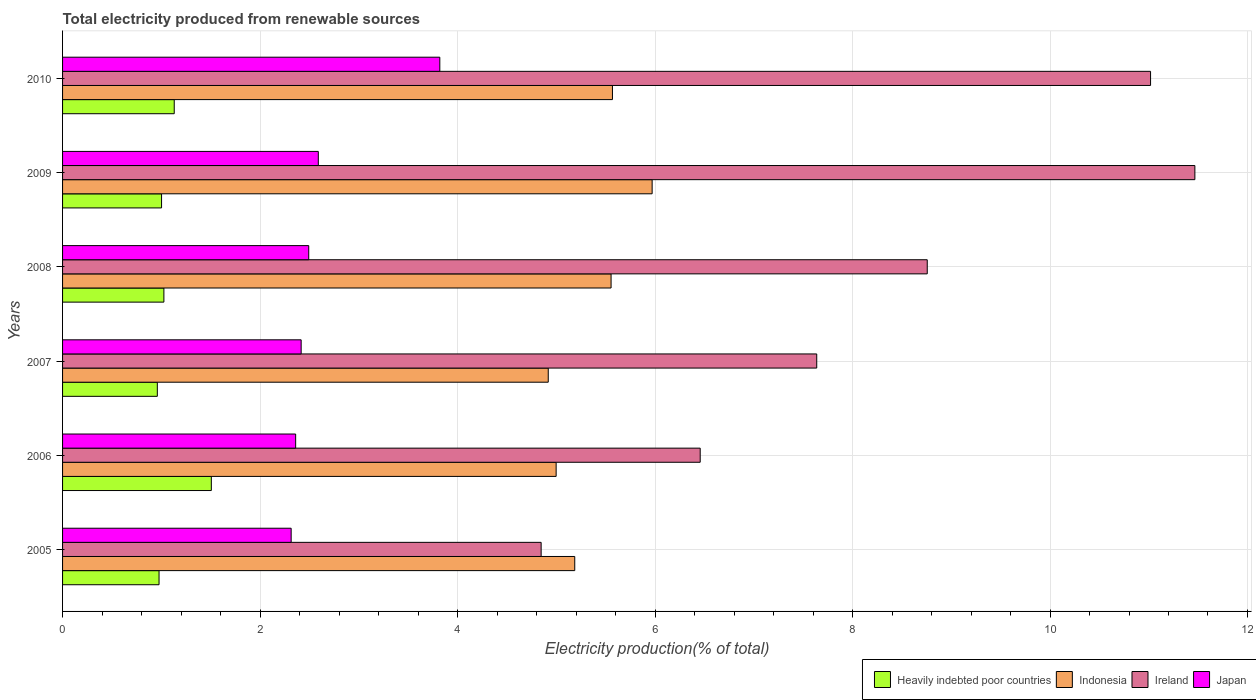How many different coloured bars are there?
Provide a succinct answer. 4. How many groups of bars are there?
Keep it short and to the point. 6. In how many cases, is the number of bars for a given year not equal to the number of legend labels?
Offer a terse response. 0. What is the total electricity produced in Heavily indebted poor countries in 2007?
Offer a very short reply. 0.96. Across all years, what is the maximum total electricity produced in Japan?
Your response must be concise. 3.82. Across all years, what is the minimum total electricity produced in Ireland?
Provide a short and direct response. 4.85. What is the total total electricity produced in Indonesia in the graph?
Ensure brevity in your answer.  32.2. What is the difference between the total electricity produced in Indonesia in 2005 and that in 2010?
Your response must be concise. -0.38. What is the difference between the total electricity produced in Japan in 2009 and the total electricity produced in Ireland in 2008?
Offer a terse response. -6.17. What is the average total electricity produced in Indonesia per year?
Your response must be concise. 5.37. In the year 2008, what is the difference between the total electricity produced in Indonesia and total electricity produced in Japan?
Ensure brevity in your answer.  3.06. What is the ratio of the total electricity produced in Heavily indebted poor countries in 2006 to that in 2007?
Keep it short and to the point. 1.57. Is the total electricity produced in Indonesia in 2009 less than that in 2010?
Ensure brevity in your answer.  No. Is the difference between the total electricity produced in Indonesia in 2005 and 2009 greater than the difference between the total electricity produced in Japan in 2005 and 2009?
Offer a terse response. No. What is the difference between the highest and the second highest total electricity produced in Indonesia?
Give a very brief answer. 0.4. What is the difference between the highest and the lowest total electricity produced in Japan?
Make the answer very short. 1.51. What does the 3rd bar from the top in 2009 represents?
Keep it short and to the point. Indonesia. What does the 1st bar from the bottom in 2005 represents?
Your answer should be very brief. Heavily indebted poor countries. Is it the case that in every year, the sum of the total electricity produced in Japan and total electricity produced in Heavily indebted poor countries is greater than the total electricity produced in Ireland?
Your answer should be very brief. No. How many bars are there?
Give a very brief answer. 24. Are all the bars in the graph horizontal?
Your answer should be very brief. Yes. What is the difference between two consecutive major ticks on the X-axis?
Keep it short and to the point. 2. Are the values on the major ticks of X-axis written in scientific E-notation?
Offer a very short reply. No. What is the title of the graph?
Offer a very short reply. Total electricity produced from renewable sources. Does "Grenada" appear as one of the legend labels in the graph?
Your answer should be very brief. No. What is the label or title of the Y-axis?
Your response must be concise. Years. What is the Electricity production(% of total) in Heavily indebted poor countries in 2005?
Ensure brevity in your answer.  0.98. What is the Electricity production(% of total) of Indonesia in 2005?
Ensure brevity in your answer.  5.19. What is the Electricity production(% of total) of Ireland in 2005?
Provide a succinct answer. 4.85. What is the Electricity production(% of total) in Japan in 2005?
Offer a terse response. 2.31. What is the Electricity production(% of total) of Heavily indebted poor countries in 2006?
Keep it short and to the point. 1.51. What is the Electricity production(% of total) in Indonesia in 2006?
Give a very brief answer. 5. What is the Electricity production(% of total) in Ireland in 2006?
Your answer should be compact. 6.46. What is the Electricity production(% of total) in Japan in 2006?
Your answer should be compact. 2.36. What is the Electricity production(% of total) of Heavily indebted poor countries in 2007?
Give a very brief answer. 0.96. What is the Electricity production(% of total) in Indonesia in 2007?
Your answer should be compact. 4.92. What is the Electricity production(% of total) in Ireland in 2007?
Your answer should be compact. 7.64. What is the Electricity production(% of total) of Japan in 2007?
Ensure brevity in your answer.  2.42. What is the Electricity production(% of total) of Heavily indebted poor countries in 2008?
Keep it short and to the point. 1.03. What is the Electricity production(% of total) in Indonesia in 2008?
Provide a succinct answer. 5.56. What is the Electricity production(% of total) of Ireland in 2008?
Give a very brief answer. 8.76. What is the Electricity production(% of total) of Japan in 2008?
Ensure brevity in your answer.  2.49. What is the Electricity production(% of total) of Heavily indebted poor countries in 2009?
Your answer should be compact. 1. What is the Electricity production(% of total) of Indonesia in 2009?
Provide a succinct answer. 5.97. What is the Electricity production(% of total) of Ireland in 2009?
Your answer should be compact. 11.47. What is the Electricity production(% of total) in Japan in 2009?
Provide a succinct answer. 2.59. What is the Electricity production(% of total) of Heavily indebted poor countries in 2010?
Your answer should be very brief. 1.13. What is the Electricity production(% of total) of Indonesia in 2010?
Your answer should be compact. 5.57. What is the Electricity production(% of total) in Ireland in 2010?
Your answer should be compact. 11.02. What is the Electricity production(% of total) in Japan in 2010?
Your response must be concise. 3.82. Across all years, what is the maximum Electricity production(% of total) of Heavily indebted poor countries?
Make the answer very short. 1.51. Across all years, what is the maximum Electricity production(% of total) in Indonesia?
Your response must be concise. 5.97. Across all years, what is the maximum Electricity production(% of total) in Ireland?
Give a very brief answer. 11.47. Across all years, what is the maximum Electricity production(% of total) in Japan?
Offer a very short reply. 3.82. Across all years, what is the minimum Electricity production(% of total) of Heavily indebted poor countries?
Give a very brief answer. 0.96. Across all years, what is the minimum Electricity production(% of total) in Indonesia?
Your answer should be compact. 4.92. Across all years, what is the minimum Electricity production(% of total) of Ireland?
Give a very brief answer. 4.85. Across all years, what is the minimum Electricity production(% of total) of Japan?
Your response must be concise. 2.31. What is the total Electricity production(% of total) in Heavily indebted poor countries in the graph?
Make the answer very short. 6.6. What is the total Electricity production(% of total) of Indonesia in the graph?
Your answer should be compact. 32.2. What is the total Electricity production(% of total) in Ireland in the graph?
Make the answer very short. 50.18. What is the total Electricity production(% of total) of Japan in the graph?
Offer a terse response. 16. What is the difference between the Electricity production(% of total) in Heavily indebted poor countries in 2005 and that in 2006?
Your answer should be very brief. -0.53. What is the difference between the Electricity production(% of total) in Indonesia in 2005 and that in 2006?
Give a very brief answer. 0.19. What is the difference between the Electricity production(% of total) in Ireland in 2005 and that in 2006?
Provide a short and direct response. -1.61. What is the difference between the Electricity production(% of total) in Japan in 2005 and that in 2006?
Ensure brevity in your answer.  -0.05. What is the difference between the Electricity production(% of total) in Heavily indebted poor countries in 2005 and that in 2007?
Keep it short and to the point. 0.02. What is the difference between the Electricity production(% of total) of Indonesia in 2005 and that in 2007?
Your response must be concise. 0.27. What is the difference between the Electricity production(% of total) in Ireland in 2005 and that in 2007?
Make the answer very short. -2.79. What is the difference between the Electricity production(% of total) of Japan in 2005 and that in 2007?
Offer a very short reply. -0.1. What is the difference between the Electricity production(% of total) of Heavily indebted poor countries in 2005 and that in 2008?
Give a very brief answer. -0.05. What is the difference between the Electricity production(% of total) of Indonesia in 2005 and that in 2008?
Keep it short and to the point. -0.37. What is the difference between the Electricity production(% of total) of Ireland in 2005 and that in 2008?
Keep it short and to the point. -3.91. What is the difference between the Electricity production(% of total) of Japan in 2005 and that in 2008?
Keep it short and to the point. -0.18. What is the difference between the Electricity production(% of total) of Heavily indebted poor countries in 2005 and that in 2009?
Offer a very short reply. -0.03. What is the difference between the Electricity production(% of total) in Indonesia in 2005 and that in 2009?
Your answer should be compact. -0.78. What is the difference between the Electricity production(% of total) of Ireland in 2005 and that in 2009?
Ensure brevity in your answer.  -6.62. What is the difference between the Electricity production(% of total) in Japan in 2005 and that in 2009?
Your answer should be compact. -0.28. What is the difference between the Electricity production(% of total) in Heavily indebted poor countries in 2005 and that in 2010?
Your answer should be very brief. -0.15. What is the difference between the Electricity production(% of total) in Indonesia in 2005 and that in 2010?
Provide a short and direct response. -0.38. What is the difference between the Electricity production(% of total) of Ireland in 2005 and that in 2010?
Your answer should be very brief. -6.17. What is the difference between the Electricity production(% of total) of Japan in 2005 and that in 2010?
Give a very brief answer. -1.51. What is the difference between the Electricity production(% of total) of Heavily indebted poor countries in 2006 and that in 2007?
Your answer should be very brief. 0.55. What is the difference between the Electricity production(% of total) in Indonesia in 2006 and that in 2007?
Give a very brief answer. 0.08. What is the difference between the Electricity production(% of total) of Ireland in 2006 and that in 2007?
Offer a very short reply. -1.18. What is the difference between the Electricity production(% of total) in Japan in 2006 and that in 2007?
Ensure brevity in your answer.  -0.06. What is the difference between the Electricity production(% of total) in Heavily indebted poor countries in 2006 and that in 2008?
Your answer should be compact. 0.48. What is the difference between the Electricity production(% of total) in Indonesia in 2006 and that in 2008?
Your answer should be very brief. -0.56. What is the difference between the Electricity production(% of total) in Ireland in 2006 and that in 2008?
Provide a short and direct response. -2.3. What is the difference between the Electricity production(% of total) of Japan in 2006 and that in 2008?
Offer a very short reply. -0.13. What is the difference between the Electricity production(% of total) of Heavily indebted poor countries in 2006 and that in 2009?
Keep it short and to the point. 0.5. What is the difference between the Electricity production(% of total) in Indonesia in 2006 and that in 2009?
Provide a succinct answer. -0.97. What is the difference between the Electricity production(% of total) in Ireland in 2006 and that in 2009?
Offer a very short reply. -5.01. What is the difference between the Electricity production(% of total) of Japan in 2006 and that in 2009?
Your answer should be compact. -0.23. What is the difference between the Electricity production(% of total) of Heavily indebted poor countries in 2006 and that in 2010?
Give a very brief answer. 0.38. What is the difference between the Electricity production(% of total) in Indonesia in 2006 and that in 2010?
Offer a terse response. -0.57. What is the difference between the Electricity production(% of total) of Ireland in 2006 and that in 2010?
Provide a succinct answer. -4.56. What is the difference between the Electricity production(% of total) in Japan in 2006 and that in 2010?
Offer a very short reply. -1.46. What is the difference between the Electricity production(% of total) of Heavily indebted poor countries in 2007 and that in 2008?
Provide a succinct answer. -0.07. What is the difference between the Electricity production(% of total) of Indonesia in 2007 and that in 2008?
Provide a short and direct response. -0.64. What is the difference between the Electricity production(% of total) of Ireland in 2007 and that in 2008?
Make the answer very short. -1.12. What is the difference between the Electricity production(% of total) in Japan in 2007 and that in 2008?
Provide a short and direct response. -0.08. What is the difference between the Electricity production(% of total) in Heavily indebted poor countries in 2007 and that in 2009?
Offer a very short reply. -0.04. What is the difference between the Electricity production(% of total) of Indonesia in 2007 and that in 2009?
Your response must be concise. -1.05. What is the difference between the Electricity production(% of total) of Ireland in 2007 and that in 2009?
Ensure brevity in your answer.  -3.83. What is the difference between the Electricity production(% of total) of Japan in 2007 and that in 2009?
Offer a very short reply. -0.17. What is the difference between the Electricity production(% of total) of Heavily indebted poor countries in 2007 and that in 2010?
Make the answer very short. -0.17. What is the difference between the Electricity production(% of total) of Indonesia in 2007 and that in 2010?
Make the answer very short. -0.65. What is the difference between the Electricity production(% of total) in Ireland in 2007 and that in 2010?
Make the answer very short. -3.38. What is the difference between the Electricity production(% of total) of Japan in 2007 and that in 2010?
Your response must be concise. -1.4. What is the difference between the Electricity production(% of total) of Heavily indebted poor countries in 2008 and that in 2009?
Give a very brief answer. 0.02. What is the difference between the Electricity production(% of total) in Indonesia in 2008 and that in 2009?
Your answer should be very brief. -0.42. What is the difference between the Electricity production(% of total) in Ireland in 2008 and that in 2009?
Your answer should be very brief. -2.71. What is the difference between the Electricity production(% of total) of Japan in 2008 and that in 2009?
Provide a short and direct response. -0.1. What is the difference between the Electricity production(% of total) of Heavily indebted poor countries in 2008 and that in 2010?
Make the answer very short. -0.1. What is the difference between the Electricity production(% of total) of Indonesia in 2008 and that in 2010?
Your response must be concise. -0.01. What is the difference between the Electricity production(% of total) in Ireland in 2008 and that in 2010?
Provide a short and direct response. -2.26. What is the difference between the Electricity production(% of total) in Japan in 2008 and that in 2010?
Your answer should be very brief. -1.33. What is the difference between the Electricity production(% of total) of Heavily indebted poor countries in 2009 and that in 2010?
Your answer should be compact. -0.13. What is the difference between the Electricity production(% of total) of Indonesia in 2009 and that in 2010?
Ensure brevity in your answer.  0.4. What is the difference between the Electricity production(% of total) of Ireland in 2009 and that in 2010?
Ensure brevity in your answer.  0.45. What is the difference between the Electricity production(% of total) in Japan in 2009 and that in 2010?
Keep it short and to the point. -1.23. What is the difference between the Electricity production(% of total) in Heavily indebted poor countries in 2005 and the Electricity production(% of total) in Indonesia in 2006?
Your response must be concise. -4.02. What is the difference between the Electricity production(% of total) of Heavily indebted poor countries in 2005 and the Electricity production(% of total) of Ireland in 2006?
Ensure brevity in your answer.  -5.48. What is the difference between the Electricity production(% of total) in Heavily indebted poor countries in 2005 and the Electricity production(% of total) in Japan in 2006?
Provide a short and direct response. -1.38. What is the difference between the Electricity production(% of total) in Indonesia in 2005 and the Electricity production(% of total) in Ireland in 2006?
Offer a very short reply. -1.27. What is the difference between the Electricity production(% of total) of Indonesia in 2005 and the Electricity production(% of total) of Japan in 2006?
Give a very brief answer. 2.83. What is the difference between the Electricity production(% of total) in Ireland in 2005 and the Electricity production(% of total) in Japan in 2006?
Keep it short and to the point. 2.49. What is the difference between the Electricity production(% of total) in Heavily indebted poor countries in 2005 and the Electricity production(% of total) in Indonesia in 2007?
Your answer should be very brief. -3.94. What is the difference between the Electricity production(% of total) in Heavily indebted poor countries in 2005 and the Electricity production(% of total) in Ireland in 2007?
Offer a very short reply. -6.66. What is the difference between the Electricity production(% of total) in Heavily indebted poor countries in 2005 and the Electricity production(% of total) in Japan in 2007?
Ensure brevity in your answer.  -1.44. What is the difference between the Electricity production(% of total) in Indonesia in 2005 and the Electricity production(% of total) in Ireland in 2007?
Your answer should be compact. -2.45. What is the difference between the Electricity production(% of total) in Indonesia in 2005 and the Electricity production(% of total) in Japan in 2007?
Keep it short and to the point. 2.77. What is the difference between the Electricity production(% of total) in Ireland in 2005 and the Electricity production(% of total) in Japan in 2007?
Your response must be concise. 2.43. What is the difference between the Electricity production(% of total) of Heavily indebted poor countries in 2005 and the Electricity production(% of total) of Indonesia in 2008?
Ensure brevity in your answer.  -4.58. What is the difference between the Electricity production(% of total) in Heavily indebted poor countries in 2005 and the Electricity production(% of total) in Ireland in 2008?
Your answer should be very brief. -7.78. What is the difference between the Electricity production(% of total) of Heavily indebted poor countries in 2005 and the Electricity production(% of total) of Japan in 2008?
Give a very brief answer. -1.52. What is the difference between the Electricity production(% of total) in Indonesia in 2005 and the Electricity production(% of total) in Ireland in 2008?
Your response must be concise. -3.57. What is the difference between the Electricity production(% of total) of Indonesia in 2005 and the Electricity production(% of total) of Japan in 2008?
Make the answer very short. 2.69. What is the difference between the Electricity production(% of total) in Ireland in 2005 and the Electricity production(% of total) in Japan in 2008?
Offer a very short reply. 2.35. What is the difference between the Electricity production(% of total) in Heavily indebted poor countries in 2005 and the Electricity production(% of total) in Indonesia in 2009?
Your response must be concise. -4.99. What is the difference between the Electricity production(% of total) in Heavily indebted poor countries in 2005 and the Electricity production(% of total) in Ireland in 2009?
Provide a short and direct response. -10.49. What is the difference between the Electricity production(% of total) of Heavily indebted poor countries in 2005 and the Electricity production(% of total) of Japan in 2009?
Your answer should be very brief. -1.61. What is the difference between the Electricity production(% of total) of Indonesia in 2005 and the Electricity production(% of total) of Ireland in 2009?
Give a very brief answer. -6.28. What is the difference between the Electricity production(% of total) of Indonesia in 2005 and the Electricity production(% of total) of Japan in 2009?
Give a very brief answer. 2.6. What is the difference between the Electricity production(% of total) in Ireland in 2005 and the Electricity production(% of total) in Japan in 2009?
Offer a terse response. 2.26. What is the difference between the Electricity production(% of total) of Heavily indebted poor countries in 2005 and the Electricity production(% of total) of Indonesia in 2010?
Keep it short and to the point. -4.59. What is the difference between the Electricity production(% of total) in Heavily indebted poor countries in 2005 and the Electricity production(% of total) in Ireland in 2010?
Provide a succinct answer. -10.04. What is the difference between the Electricity production(% of total) of Heavily indebted poor countries in 2005 and the Electricity production(% of total) of Japan in 2010?
Your answer should be very brief. -2.84. What is the difference between the Electricity production(% of total) of Indonesia in 2005 and the Electricity production(% of total) of Ireland in 2010?
Offer a very short reply. -5.83. What is the difference between the Electricity production(% of total) in Indonesia in 2005 and the Electricity production(% of total) in Japan in 2010?
Ensure brevity in your answer.  1.37. What is the difference between the Electricity production(% of total) in Ireland in 2005 and the Electricity production(% of total) in Japan in 2010?
Ensure brevity in your answer.  1.03. What is the difference between the Electricity production(% of total) in Heavily indebted poor countries in 2006 and the Electricity production(% of total) in Indonesia in 2007?
Keep it short and to the point. -3.41. What is the difference between the Electricity production(% of total) of Heavily indebted poor countries in 2006 and the Electricity production(% of total) of Ireland in 2007?
Offer a very short reply. -6.13. What is the difference between the Electricity production(% of total) in Heavily indebted poor countries in 2006 and the Electricity production(% of total) in Japan in 2007?
Your answer should be compact. -0.91. What is the difference between the Electricity production(% of total) in Indonesia in 2006 and the Electricity production(% of total) in Ireland in 2007?
Keep it short and to the point. -2.64. What is the difference between the Electricity production(% of total) in Indonesia in 2006 and the Electricity production(% of total) in Japan in 2007?
Give a very brief answer. 2.58. What is the difference between the Electricity production(% of total) in Ireland in 2006 and the Electricity production(% of total) in Japan in 2007?
Provide a succinct answer. 4.04. What is the difference between the Electricity production(% of total) in Heavily indebted poor countries in 2006 and the Electricity production(% of total) in Indonesia in 2008?
Make the answer very short. -4.05. What is the difference between the Electricity production(% of total) in Heavily indebted poor countries in 2006 and the Electricity production(% of total) in Ireland in 2008?
Make the answer very short. -7.25. What is the difference between the Electricity production(% of total) of Heavily indebted poor countries in 2006 and the Electricity production(% of total) of Japan in 2008?
Offer a terse response. -0.99. What is the difference between the Electricity production(% of total) of Indonesia in 2006 and the Electricity production(% of total) of Ireland in 2008?
Give a very brief answer. -3.76. What is the difference between the Electricity production(% of total) of Indonesia in 2006 and the Electricity production(% of total) of Japan in 2008?
Your answer should be compact. 2.51. What is the difference between the Electricity production(% of total) of Ireland in 2006 and the Electricity production(% of total) of Japan in 2008?
Ensure brevity in your answer.  3.96. What is the difference between the Electricity production(% of total) in Heavily indebted poor countries in 2006 and the Electricity production(% of total) in Indonesia in 2009?
Offer a very short reply. -4.46. What is the difference between the Electricity production(% of total) in Heavily indebted poor countries in 2006 and the Electricity production(% of total) in Ireland in 2009?
Provide a succinct answer. -9.96. What is the difference between the Electricity production(% of total) of Heavily indebted poor countries in 2006 and the Electricity production(% of total) of Japan in 2009?
Offer a very short reply. -1.08. What is the difference between the Electricity production(% of total) in Indonesia in 2006 and the Electricity production(% of total) in Ireland in 2009?
Keep it short and to the point. -6.47. What is the difference between the Electricity production(% of total) in Indonesia in 2006 and the Electricity production(% of total) in Japan in 2009?
Keep it short and to the point. 2.41. What is the difference between the Electricity production(% of total) of Ireland in 2006 and the Electricity production(% of total) of Japan in 2009?
Give a very brief answer. 3.87. What is the difference between the Electricity production(% of total) of Heavily indebted poor countries in 2006 and the Electricity production(% of total) of Indonesia in 2010?
Your answer should be very brief. -4.06. What is the difference between the Electricity production(% of total) in Heavily indebted poor countries in 2006 and the Electricity production(% of total) in Ireland in 2010?
Provide a succinct answer. -9.51. What is the difference between the Electricity production(% of total) of Heavily indebted poor countries in 2006 and the Electricity production(% of total) of Japan in 2010?
Your answer should be compact. -2.31. What is the difference between the Electricity production(% of total) in Indonesia in 2006 and the Electricity production(% of total) in Ireland in 2010?
Your answer should be very brief. -6.02. What is the difference between the Electricity production(% of total) in Indonesia in 2006 and the Electricity production(% of total) in Japan in 2010?
Offer a terse response. 1.18. What is the difference between the Electricity production(% of total) in Ireland in 2006 and the Electricity production(% of total) in Japan in 2010?
Your response must be concise. 2.64. What is the difference between the Electricity production(% of total) in Heavily indebted poor countries in 2007 and the Electricity production(% of total) in Indonesia in 2008?
Your response must be concise. -4.6. What is the difference between the Electricity production(% of total) in Heavily indebted poor countries in 2007 and the Electricity production(% of total) in Ireland in 2008?
Provide a succinct answer. -7.8. What is the difference between the Electricity production(% of total) of Heavily indebted poor countries in 2007 and the Electricity production(% of total) of Japan in 2008?
Keep it short and to the point. -1.53. What is the difference between the Electricity production(% of total) in Indonesia in 2007 and the Electricity production(% of total) in Ireland in 2008?
Your answer should be very brief. -3.84. What is the difference between the Electricity production(% of total) of Indonesia in 2007 and the Electricity production(% of total) of Japan in 2008?
Give a very brief answer. 2.43. What is the difference between the Electricity production(% of total) in Ireland in 2007 and the Electricity production(% of total) in Japan in 2008?
Provide a succinct answer. 5.14. What is the difference between the Electricity production(% of total) in Heavily indebted poor countries in 2007 and the Electricity production(% of total) in Indonesia in 2009?
Provide a succinct answer. -5.01. What is the difference between the Electricity production(% of total) in Heavily indebted poor countries in 2007 and the Electricity production(% of total) in Ireland in 2009?
Provide a succinct answer. -10.51. What is the difference between the Electricity production(% of total) of Heavily indebted poor countries in 2007 and the Electricity production(% of total) of Japan in 2009?
Make the answer very short. -1.63. What is the difference between the Electricity production(% of total) of Indonesia in 2007 and the Electricity production(% of total) of Ireland in 2009?
Keep it short and to the point. -6.55. What is the difference between the Electricity production(% of total) of Indonesia in 2007 and the Electricity production(% of total) of Japan in 2009?
Offer a terse response. 2.33. What is the difference between the Electricity production(% of total) of Ireland in 2007 and the Electricity production(% of total) of Japan in 2009?
Provide a short and direct response. 5.05. What is the difference between the Electricity production(% of total) in Heavily indebted poor countries in 2007 and the Electricity production(% of total) in Indonesia in 2010?
Your answer should be very brief. -4.61. What is the difference between the Electricity production(% of total) of Heavily indebted poor countries in 2007 and the Electricity production(% of total) of Ireland in 2010?
Your response must be concise. -10.06. What is the difference between the Electricity production(% of total) in Heavily indebted poor countries in 2007 and the Electricity production(% of total) in Japan in 2010?
Provide a succinct answer. -2.86. What is the difference between the Electricity production(% of total) in Indonesia in 2007 and the Electricity production(% of total) in Ireland in 2010?
Give a very brief answer. -6.1. What is the difference between the Electricity production(% of total) of Indonesia in 2007 and the Electricity production(% of total) of Japan in 2010?
Make the answer very short. 1.1. What is the difference between the Electricity production(% of total) in Ireland in 2007 and the Electricity production(% of total) in Japan in 2010?
Keep it short and to the point. 3.82. What is the difference between the Electricity production(% of total) of Heavily indebted poor countries in 2008 and the Electricity production(% of total) of Indonesia in 2009?
Your answer should be compact. -4.94. What is the difference between the Electricity production(% of total) in Heavily indebted poor countries in 2008 and the Electricity production(% of total) in Ireland in 2009?
Your answer should be compact. -10.44. What is the difference between the Electricity production(% of total) in Heavily indebted poor countries in 2008 and the Electricity production(% of total) in Japan in 2009?
Offer a very short reply. -1.56. What is the difference between the Electricity production(% of total) in Indonesia in 2008 and the Electricity production(% of total) in Ireland in 2009?
Offer a very short reply. -5.91. What is the difference between the Electricity production(% of total) of Indonesia in 2008 and the Electricity production(% of total) of Japan in 2009?
Give a very brief answer. 2.96. What is the difference between the Electricity production(% of total) in Ireland in 2008 and the Electricity production(% of total) in Japan in 2009?
Offer a terse response. 6.17. What is the difference between the Electricity production(% of total) in Heavily indebted poor countries in 2008 and the Electricity production(% of total) in Indonesia in 2010?
Make the answer very short. -4.54. What is the difference between the Electricity production(% of total) in Heavily indebted poor countries in 2008 and the Electricity production(% of total) in Ireland in 2010?
Provide a short and direct response. -9.99. What is the difference between the Electricity production(% of total) of Heavily indebted poor countries in 2008 and the Electricity production(% of total) of Japan in 2010?
Ensure brevity in your answer.  -2.79. What is the difference between the Electricity production(% of total) in Indonesia in 2008 and the Electricity production(% of total) in Ireland in 2010?
Provide a short and direct response. -5.46. What is the difference between the Electricity production(% of total) in Indonesia in 2008 and the Electricity production(% of total) in Japan in 2010?
Offer a very short reply. 1.73. What is the difference between the Electricity production(% of total) in Ireland in 2008 and the Electricity production(% of total) in Japan in 2010?
Offer a very short reply. 4.94. What is the difference between the Electricity production(% of total) of Heavily indebted poor countries in 2009 and the Electricity production(% of total) of Indonesia in 2010?
Keep it short and to the point. -4.57. What is the difference between the Electricity production(% of total) in Heavily indebted poor countries in 2009 and the Electricity production(% of total) in Ireland in 2010?
Provide a succinct answer. -10.02. What is the difference between the Electricity production(% of total) of Heavily indebted poor countries in 2009 and the Electricity production(% of total) of Japan in 2010?
Provide a short and direct response. -2.82. What is the difference between the Electricity production(% of total) in Indonesia in 2009 and the Electricity production(% of total) in Ireland in 2010?
Provide a short and direct response. -5.05. What is the difference between the Electricity production(% of total) of Indonesia in 2009 and the Electricity production(% of total) of Japan in 2010?
Provide a short and direct response. 2.15. What is the difference between the Electricity production(% of total) in Ireland in 2009 and the Electricity production(% of total) in Japan in 2010?
Provide a short and direct response. 7.65. What is the average Electricity production(% of total) in Heavily indebted poor countries per year?
Your response must be concise. 1.1. What is the average Electricity production(% of total) in Indonesia per year?
Ensure brevity in your answer.  5.37. What is the average Electricity production(% of total) of Ireland per year?
Provide a succinct answer. 8.36. What is the average Electricity production(% of total) of Japan per year?
Ensure brevity in your answer.  2.67. In the year 2005, what is the difference between the Electricity production(% of total) of Heavily indebted poor countries and Electricity production(% of total) of Indonesia?
Your answer should be very brief. -4.21. In the year 2005, what is the difference between the Electricity production(% of total) of Heavily indebted poor countries and Electricity production(% of total) of Ireland?
Provide a short and direct response. -3.87. In the year 2005, what is the difference between the Electricity production(% of total) of Heavily indebted poor countries and Electricity production(% of total) of Japan?
Keep it short and to the point. -1.34. In the year 2005, what is the difference between the Electricity production(% of total) in Indonesia and Electricity production(% of total) in Ireland?
Provide a short and direct response. 0.34. In the year 2005, what is the difference between the Electricity production(% of total) in Indonesia and Electricity production(% of total) in Japan?
Give a very brief answer. 2.87. In the year 2005, what is the difference between the Electricity production(% of total) in Ireland and Electricity production(% of total) in Japan?
Your answer should be very brief. 2.53. In the year 2006, what is the difference between the Electricity production(% of total) in Heavily indebted poor countries and Electricity production(% of total) in Indonesia?
Offer a very short reply. -3.49. In the year 2006, what is the difference between the Electricity production(% of total) of Heavily indebted poor countries and Electricity production(% of total) of Ireland?
Offer a very short reply. -4.95. In the year 2006, what is the difference between the Electricity production(% of total) in Heavily indebted poor countries and Electricity production(% of total) in Japan?
Your answer should be compact. -0.85. In the year 2006, what is the difference between the Electricity production(% of total) of Indonesia and Electricity production(% of total) of Ireland?
Offer a terse response. -1.46. In the year 2006, what is the difference between the Electricity production(% of total) in Indonesia and Electricity production(% of total) in Japan?
Offer a very short reply. 2.64. In the year 2006, what is the difference between the Electricity production(% of total) of Ireland and Electricity production(% of total) of Japan?
Your answer should be compact. 4.1. In the year 2007, what is the difference between the Electricity production(% of total) in Heavily indebted poor countries and Electricity production(% of total) in Indonesia?
Provide a short and direct response. -3.96. In the year 2007, what is the difference between the Electricity production(% of total) of Heavily indebted poor countries and Electricity production(% of total) of Ireland?
Your response must be concise. -6.68. In the year 2007, what is the difference between the Electricity production(% of total) in Heavily indebted poor countries and Electricity production(% of total) in Japan?
Offer a terse response. -1.46. In the year 2007, what is the difference between the Electricity production(% of total) in Indonesia and Electricity production(% of total) in Ireland?
Give a very brief answer. -2.72. In the year 2007, what is the difference between the Electricity production(% of total) in Indonesia and Electricity production(% of total) in Japan?
Offer a very short reply. 2.5. In the year 2007, what is the difference between the Electricity production(% of total) of Ireland and Electricity production(% of total) of Japan?
Your response must be concise. 5.22. In the year 2008, what is the difference between the Electricity production(% of total) of Heavily indebted poor countries and Electricity production(% of total) of Indonesia?
Keep it short and to the point. -4.53. In the year 2008, what is the difference between the Electricity production(% of total) of Heavily indebted poor countries and Electricity production(% of total) of Ireland?
Ensure brevity in your answer.  -7.73. In the year 2008, what is the difference between the Electricity production(% of total) of Heavily indebted poor countries and Electricity production(% of total) of Japan?
Offer a very short reply. -1.47. In the year 2008, what is the difference between the Electricity production(% of total) of Indonesia and Electricity production(% of total) of Ireland?
Make the answer very short. -3.2. In the year 2008, what is the difference between the Electricity production(% of total) of Indonesia and Electricity production(% of total) of Japan?
Your answer should be compact. 3.06. In the year 2008, what is the difference between the Electricity production(% of total) of Ireland and Electricity production(% of total) of Japan?
Provide a succinct answer. 6.26. In the year 2009, what is the difference between the Electricity production(% of total) in Heavily indebted poor countries and Electricity production(% of total) in Indonesia?
Offer a very short reply. -4.97. In the year 2009, what is the difference between the Electricity production(% of total) of Heavily indebted poor countries and Electricity production(% of total) of Ireland?
Make the answer very short. -10.46. In the year 2009, what is the difference between the Electricity production(% of total) in Heavily indebted poor countries and Electricity production(% of total) in Japan?
Make the answer very short. -1.59. In the year 2009, what is the difference between the Electricity production(% of total) of Indonesia and Electricity production(% of total) of Ireland?
Provide a succinct answer. -5.5. In the year 2009, what is the difference between the Electricity production(% of total) of Indonesia and Electricity production(% of total) of Japan?
Provide a succinct answer. 3.38. In the year 2009, what is the difference between the Electricity production(% of total) of Ireland and Electricity production(% of total) of Japan?
Make the answer very short. 8.88. In the year 2010, what is the difference between the Electricity production(% of total) in Heavily indebted poor countries and Electricity production(% of total) in Indonesia?
Ensure brevity in your answer.  -4.44. In the year 2010, what is the difference between the Electricity production(% of total) in Heavily indebted poor countries and Electricity production(% of total) in Ireland?
Provide a short and direct response. -9.89. In the year 2010, what is the difference between the Electricity production(% of total) of Heavily indebted poor countries and Electricity production(% of total) of Japan?
Your answer should be very brief. -2.69. In the year 2010, what is the difference between the Electricity production(% of total) of Indonesia and Electricity production(% of total) of Ireland?
Your answer should be very brief. -5.45. In the year 2010, what is the difference between the Electricity production(% of total) in Indonesia and Electricity production(% of total) in Japan?
Keep it short and to the point. 1.75. In the year 2010, what is the difference between the Electricity production(% of total) in Ireland and Electricity production(% of total) in Japan?
Make the answer very short. 7.2. What is the ratio of the Electricity production(% of total) in Heavily indebted poor countries in 2005 to that in 2006?
Your response must be concise. 0.65. What is the ratio of the Electricity production(% of total) in Indonesia in 2005 to that in 2006?
Your response must be concise. 1.04. What is the ratio of the Electricity production(% of total) of Ireland in 2005 to that in 2006?
Provide a succinct answer. 0.75. What is the ratio of the Electricity production(% of total) of Japan in 2005 to that in 2006?
Offer a very short reply. 0.98. What is the ratio of the Electricity production(% of total) of Heavily indebted poor countries in 2005 to that in 2007?
Keep it short and to the point. 1.02. What is the ratio of the Electricity production(% of total) of Indonesia in 2005 to that in 2007?
Your answer should be very brief. 1.05. What is the ratio of the Electricity production(% of total) of Ireland in 2005 to that in 2007?
Offer a terse response. 0.63. What is the ratio of the Electricity production(% of total) in Japan in 2005 to that in 2007?
Offer a terse response. 0.96. What is the ratio of the Electricity production(% of total) in Heavily indebted poor countries in 2005 to that in 2008?
Ensure brevity in your answer.  0.95. What is the ratio of the Electricity production(% of total) of Indonesia in 2005 to that in 2008?
Your answer should be very brief. 0.93. What is the ratio of the Electricity production(% of total) in Ireland in 2005 to that in 2008?
Your response must be concise. 0.55. What is the ratio of the Electricity production(% of total) in Heavily indebted poor countries in 2005 to that in 2009?
Provide a short and direct response. 0.97. What is the ratio of the Electricity production(% of total) of Indonesia in 2005 to that in 2009?
Provide a short and direct response. 0.87. What is the ratio of the Electricity production(% of total) of Ireland in 2005 to that in 2009?
Give a very brief answer. 0.42. What is the ratio of the Electricity production(% of total) of Japan in 2005 to that in 2009?
Your response must be concise. 0.89. What is the ratio of the Electricity production(% of total) in Heavily indebted poor countries in 2005 to that in 2010?
Your answer should be very brief. 0.86. What is the ratio of the Electricity production(% of total) in Indonesia in 2005 to that in 2010?
Provide a short and direct response. 0.93. What is the ratio of the Electricity production(% of total) of Ireland in 2005 to that in 2010?
Your response must be concise. 0.44. What is the ratio of the Electricity production(% of total) in Japan in 2005 to that in 2010?
Provide a short and direct response. 0.61. What is the ratio of the Electricity production(% of total) of Heavily indebted poor countries in 2006 to that in 2007?
Ensure brevity in your answer.  1.57. What is the ratio of the Electricity production(% of total) of Indonesia in 2006 to that in 2007?
Your answer should be compact. 1.02. What is the ratio of the Electricity production(% of total) of Ireland in 2006 to that in 2007?
Keep it short and to the point. 0.85. What is the ratio of the Electricity production(% of total) of Japan in 2006 to that in 2007?
Keep it short and to the point. 0.98. What is the ratio of the Electricity production(% of total) of Heavily indebted poor countries in 2006 to that in 2008?
Provide a succinct answer. 1.47. What is the ratio of the Electricity production(% of total) of Indonesia in 2006 to that in 2008?
Offer a terse response. 0.9. What is the ratio of the Electricity production(% of total) in Ireland in 2006 to that in 2008?
Provide a short and direct response. 0.74. What is the ratio of the Electricity production(% of total) in Japan in 2006 to that in 2008?
Offer a terse response. 0.95. What is the ratio of the Electricity production(% of total) of Heavily indebted poor countries in 2006 to that in 2009?
Your answer should be very brief. 1.5. What is the ratio of the Electricity production(% of total) of Indonesia in 2006 to that in 2009?
Keep it short and to the point. 0.84. What is the ratio of the Electricity production(% of total) of Ireland in 2006 to that in 2009?
Provide a succinct answer. 0.56. What is the ratio of the Electricity production(% of total) of Japan in 2006 to that in 2009?
Offer a terse response. 0.91. What is the ratio of the Electricity production(% of total) in Heavily indebted poor countries in 2006 to that in 2010?
Offer a very short reply. 1.33. What is the ratio of the Electricity production(% of total) in Indonesia in 2006 to that in 2010?
Keep it short and to the point. 0.9. What is the ratio of the Electricity production(% of total) of Ireland in 2006 to that in 2010?
Ensure brevity in your answer.  0.59. What is the ratio of the Electricity production(% of total) of Japan in 2006 to that in 2010?
Give a very brief answer. 0.62. What is the ratio of the Electricity production(% of total) in Heavily indebted poor countries in 2007 to that in 2008?
Provide a short and direct response. 0.94. What is the ratio of the Electricity production(% of total) of Indonesia in 2007 to that in 2008?
Make the answer very short. 0.89. What is the ratio of the Electricity production(% of total) in Ireland in 2007 to that in 2008?
Provide a short and direct response. 0.87. What is the ratio of the Electricity production(% of total) of Japan in 2007 to that in 2008?
Ensure brevity in your answer.  0.97. What is the ratio of the Electricity production(% of total) of Heavily indebted poor countries in 2007 to that in 2009?
Ensure brevity in your answer.  0.96. What is the ratio of the Electricity production(% of total) in Indonesia in 2007 to that in 2009?
Your answer should be very brief. 0.82. What is the ratio of the Electricity production(% of total) of Ireland in 2007 to that in 2009?
Offer a very short reply. 0.67. What is the ratio of the Electricity production(% of total) of Japan in 2007 to that in 2009?
Offer a very short reply. 0.93. What is the ratio of the Electricity production(% of total) in Heavily indebted poor countries in 2007 to that in 2010?
Keep it short and to the point. 0.85. What is the ratio of the Electricity production(% of total) of Indonesia in 2007 to that in 2010?
Provide a succinct answer. 0.88. What is the ratio of the Electricity production(% of total) in Ireland in 2007 to that in 2010?
Offer a terse response. 0.69. What is the ratio of the Electricity production(% of total) in Japan in 2007 to that in 2010?
Offer a terse response. 0.63. What is the ratio of the Electricity production(% of total) in Heavily indebted poor countries in 2008 to that in 2009?
Provide a short and direct response. 1.02. What is the ratio of the Electricity production(% of total) in Indonesia in 2008 to that in 2009?
Give a very brief answer. 0.93. What is the ratio of the Electricity production(% of total) of Ireland in 2008 to that in 2009?
Your response must be concise. 0.76. What is the ratio of the Electricity production(% of total) in Japan in 2008 to that in 2009?
Offer a terse response. 0.96. What is the ratio of the Electricity production(% of total) in Heavily indebted poor countries in 2008 to that in 2010?
Give a very brief answer. 0.91. What is the ratio of the Electricity production(% of total) in Ireland in 2008 to that in 2010?
Keep it short and to the point. 0.79. What is the ratio of the Electricity production(% of total) of Japan in 2008 to that in 2010?
Provide a succinct answer. 0.65. What is the ratio of the Electricity production(% of total) in Heavily indebted poor countries in 2009 to that in 2010?
Keep it short and to the point. 0.89. What is the ratio of the Electricity production(% of total) of Indonesia in 2009 to that in 2010?
Give a very brief answer. 1.07. What is the ratio of the Electricity production(% of total) of Ireland in 2009 to that in 2010?
Provide a short and direct response. 1.04. What is the ratio of the Electricity production(% of total) of Japan in 2009 to that in 2010?
Ensure brevity in your answer.  0.68. What is the difference between the highest and the second highest Electricity production(% of total) in Heavily indebted poor countries?
Your answer should be compact. 0.38. What is the difference between the highest and the second highest Electricity production(% of total) of Indonesia?
Keep it short and to the point. 0.4. What is the difference between the highest and the second highest Electricity production(% of total) in Ireland?
Your response must be concise. 0.45. What is the difference between the highest and the second highest Electricity production(% of total) in Japan?
Offer a terse response. 1.23. What is the difference between the highest and the lowest Electricity production(% of total) of Heavily indebted poor countries?
Your response must be concise. 0.55. What is the difference between the highest and the lowest Electricity production(% of total) of Indonesia?
Keep it short and to the point. 1.05. What is the difference between the highest and the lowest Electricity production(% of total) in Ireland?
Provide a short and direct response. 6.62. What is the difference between the highest and the lowest Electricity production(% of total) in Japan?
Make the answer very short. 1.51. 